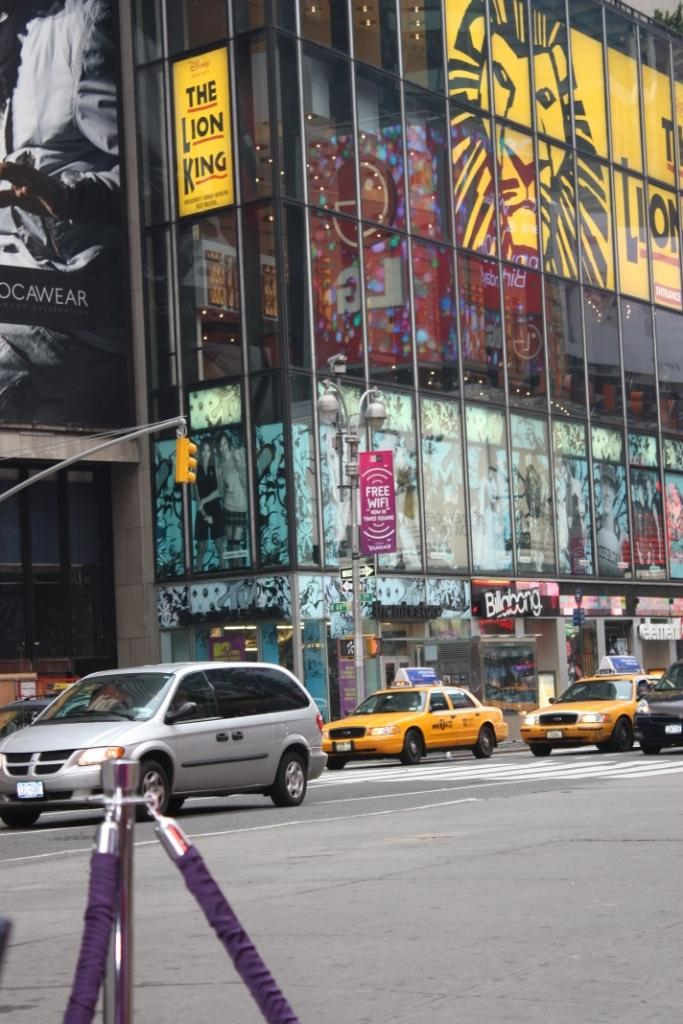Provide a one-sentence caption for the provided image. New York City streets in front of The Lion King theater with taxis parked. 